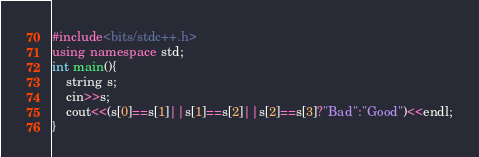<code> <loc_0><loc_0><loc_500><loc_500><_C++_>#include<bits/stdc++.h>
using namespace std;
int main(){
	string s;
	cin>>s;
	cout<<(s[0]==s[1]||s[1]==s[2]||s[2]==s[3]?"Bad":"Good")<<endl;
}
</code> 